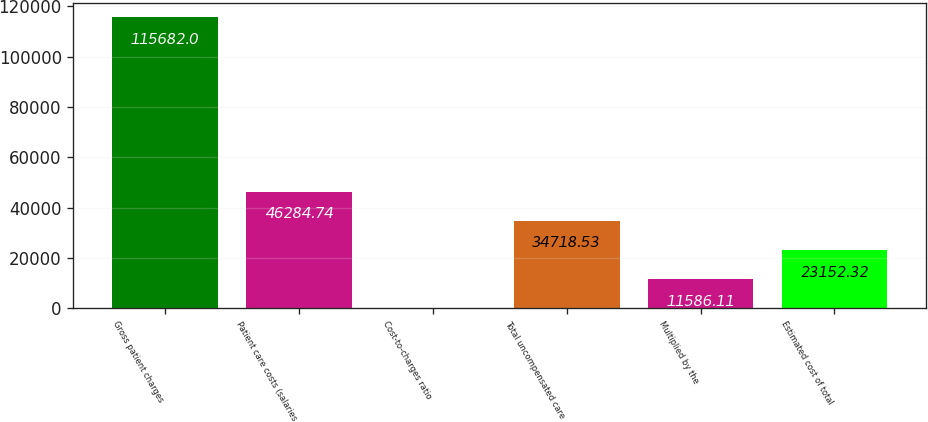Convert chart to OTSL. <chart><loc_0><loc_0><loc_500><loc_500><bar_chart><fcel>Gross patient charges<fcel>Patient care costs (salaries<fcel>Cost-to-charges ratio<fcel>Total uncompensated care<fcel>Multiplied by the<fcel>Estimated cost of total<nl><fcel>115682<fcel>46284.7<fcel>19.9<fcel>34718.5<fcel>11586.1<fcel>23152.3<nl></chart> 